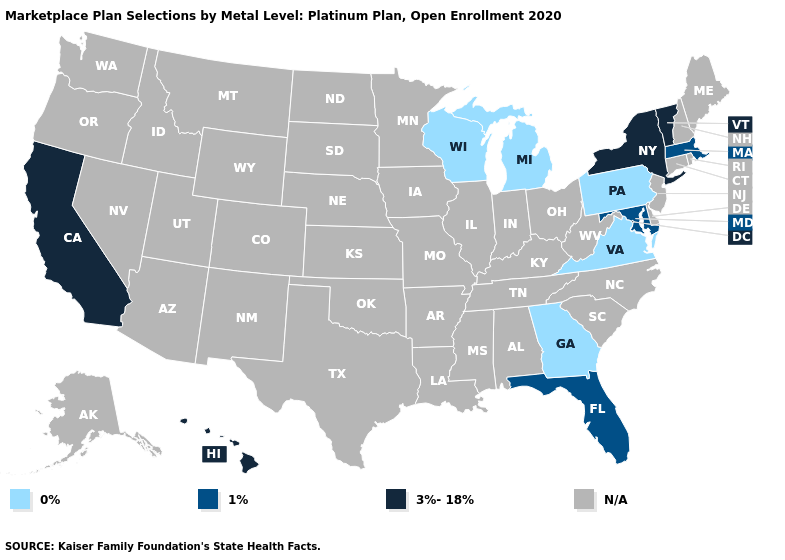What is the value of West Virginia?
Give a very brief answer. N/A. What is the highest value in the USA?
Be succinct. 3%-18%. What is the value of Oregon?
Quick response, please. N/A. What is the value of Virginia?
Concise answer only. 0%. Name the states that have a value in the range N/A?
Keep it brief. Alabama, Alaska, Arizona, Arkansas, Colorado, Connecticut, Delaware, Idaho, Illinois, Indiana, Iowa, Kansas, Kentucky, Louisiana, Maine, Minnesota, Mississippi, Missouri, Montana, Nebraska, Nevada, New Hampshire, New Jersey, New Mexico, North Carolina, North Dakota, Ohio, Oklahoma, Oregon, Rhode Island, South Carolina, South Dakota, Tennessee, Texas, Utah, Washington, West Virginia, Wyoming. What is the highest value in the MidWest ?
Give a very brief answer. 0%. Is the legend a continuous bar?
Keep it brief. No. What is the lowest value in states that border Minnesota?
Write a very short answer. 0%. Name the states that have a value in the range 0%?
Give a very brief answer. Georgia, Michigan, Pennsylvania, Virginia, Wisconsin. What is the value of Mississippi?
Answer briefly. N/A. What is the value of Missouri?
Be succinct. N/A. 